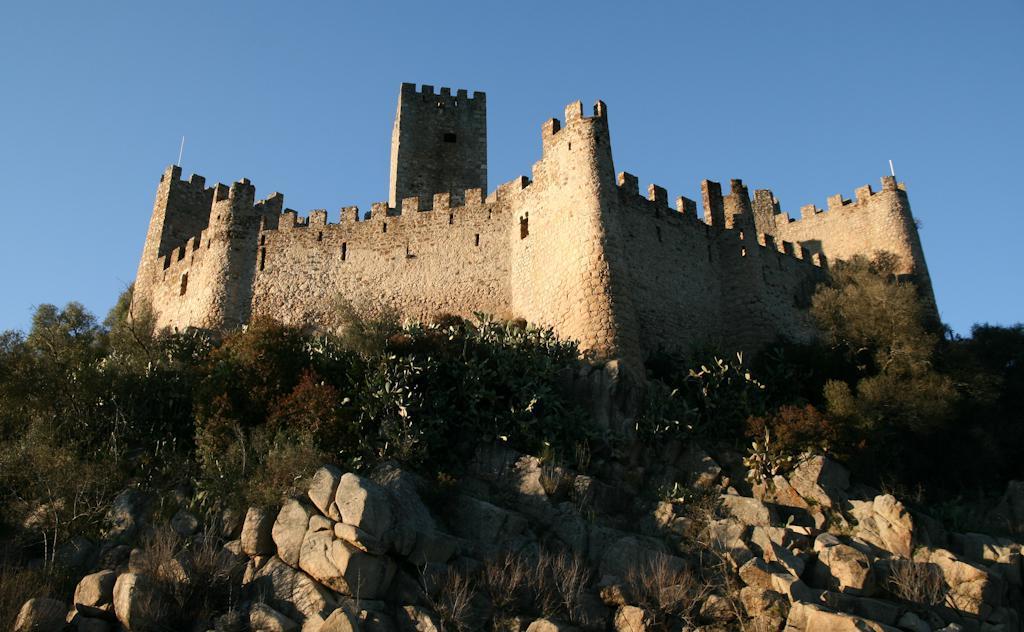Describe this image in one or two sentences. In this image at front there are rocks, trees. At the back side there is a building. At the background there is sky. 